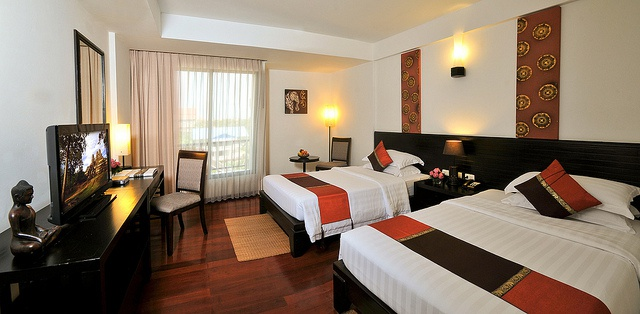Describe the objects in this image and their specific colors. I can see bed in lightgray, darkgray, and black tones, bed in lightgray, darkgray, and black tones, tv in lightgray, black, gray, maroon, and lavender tones, chair in lightgray, black, tan, and gray tones, and chair in lightgray, gray, and black tones in this image. 